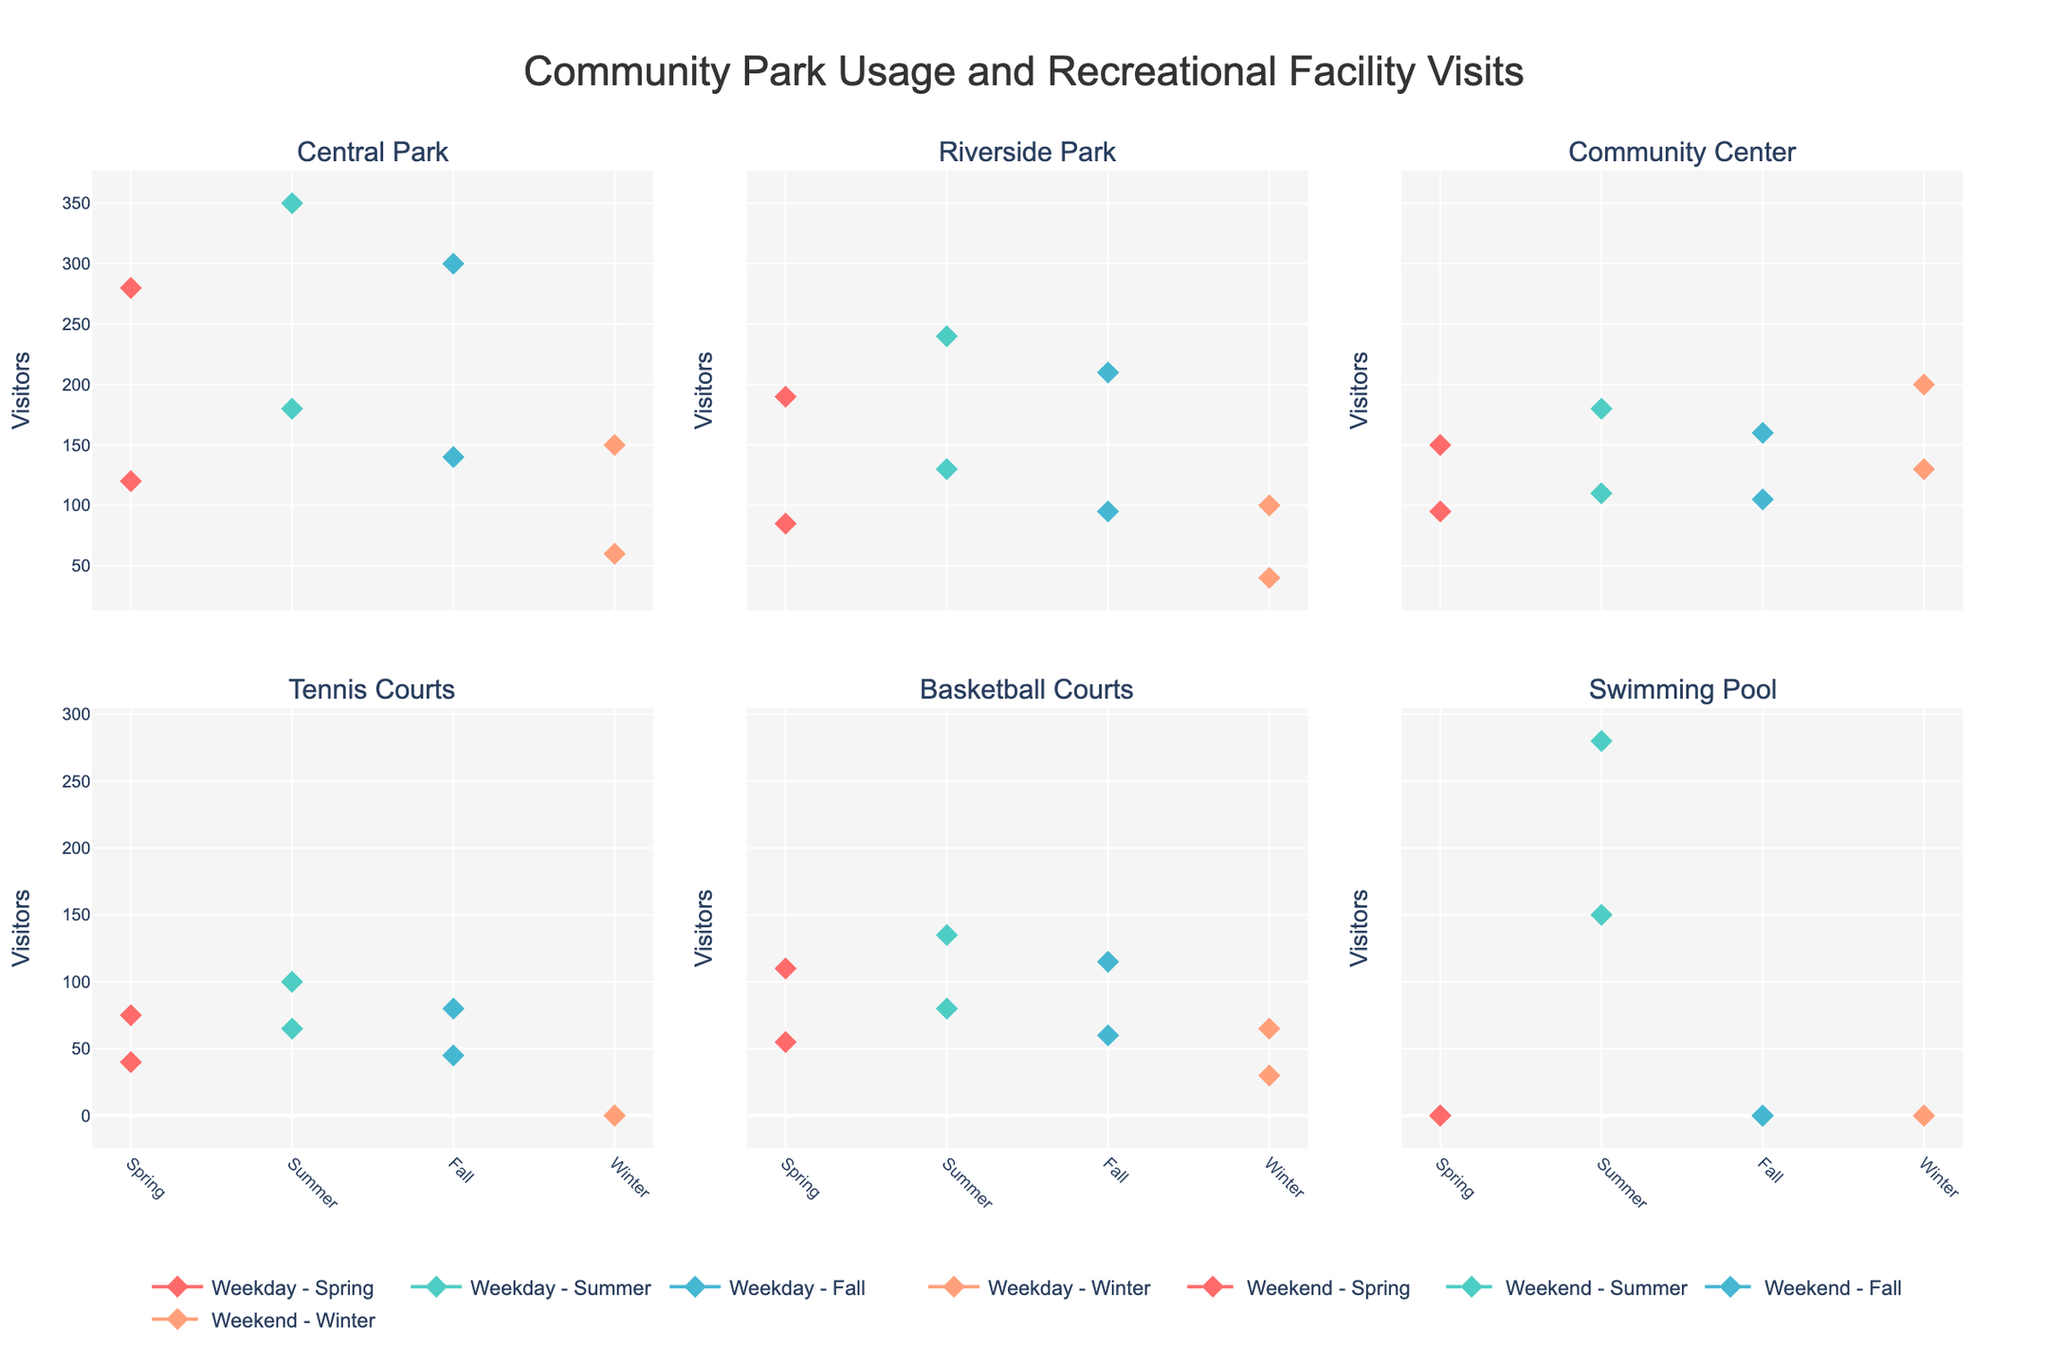What's the total number of visitors across all facilities on a summer weekend? First, tally the visitor counts for each facility on a summer weekend: Central Park (350) + Riverside (240) + Community Center (180) + Tennis Courts (100) + Basketball Courts (135) + Swimming Pool (280). Summing these gives: 350 + 240 + 180 + 100 + 135 + 280 = 1285
Answer: 1285 Which facility has the highest number of visitors on a winter weekday? Look at the data points for each facility on a winter weekday: Central Park (60), Riverside (40), Community Center (130), Tennis Courts (0), Basketball Courts (30), Swimming Pool (0). The highest number is 130 at the Community Center
Answer: Community Center Do weekends typically have more visitors compared to weekdays during the fall season for Tennis Courts? Compare the visitors for Tennis Courts during fall weekdays (45) and weekends (80). Since 80 (weekend) is greater than 45 (weekday), weekends have more visitors
Answer: Yes For Riverside Park, which day type has more visitors in the spring season? Compare the visitors for Riverside Park in spring on weekdays (85) and weekends (190). Since 190 (weekend) is greater than 85 (weekday), weekends have more visitors
Answer: Weekends How does the usage of Swimming Pools change from summer to winter weekends? Compare the number of visitors at the Swimming Pool on summer weekends (280) and in winter weekends (0). The number decreases from 280 to 0.
Answer: Decreases drastically What's the difference in visitor count between Central Park on a spring weekend and a fall weekday? Compare the visitor counts for Central Park: Spring weekend (280) and Fall weekday (140). The difference is 280 - 140 = 140
Answer: 140 Which recreational facility has no visitors during winter weekdays and weekends? Check the visitor counts for winter weekdays and weekends: Tennis Courts (Weekday: 0, Weekend: 0). No other facility has zero for both
Answer: Tennis Courts How does the number of visitors to the Basketball Courts compare between fall weekends and summer weekends? Compare the visitor counts: Fall weekends (115) and Summer weekends (135). Summer has more visitors to the Basketball Courts.
Answer: Summer What is the average number of visitors to the Community Center across all weekdays in all seasons? Sum the visitors for weekdays: Spring (95), Summer (110), Fall (105), Winter (130). The total is 95 + 110 + 105 + 130 = 440. The average is 440 / 4 = 110
Answer: 110 Is there any facility that sees an increase in visitors from fall to winter on weekends? Compare visitor counts from fall to winter weekends: Central Park (Fall: 300, Winter: 150), Riverside (Fall: 210, Winter: 100), Community Center (Fall: 160, Winter: 200), Tennis Courts (Fall: 80, Winter: 0), Basketball Courts (Fall: 115, Winter: 65), Swimming Pool (Fall: 0, Winter: 0). The Community Center sees an increase from 160 to 200
Answer: Community Center 